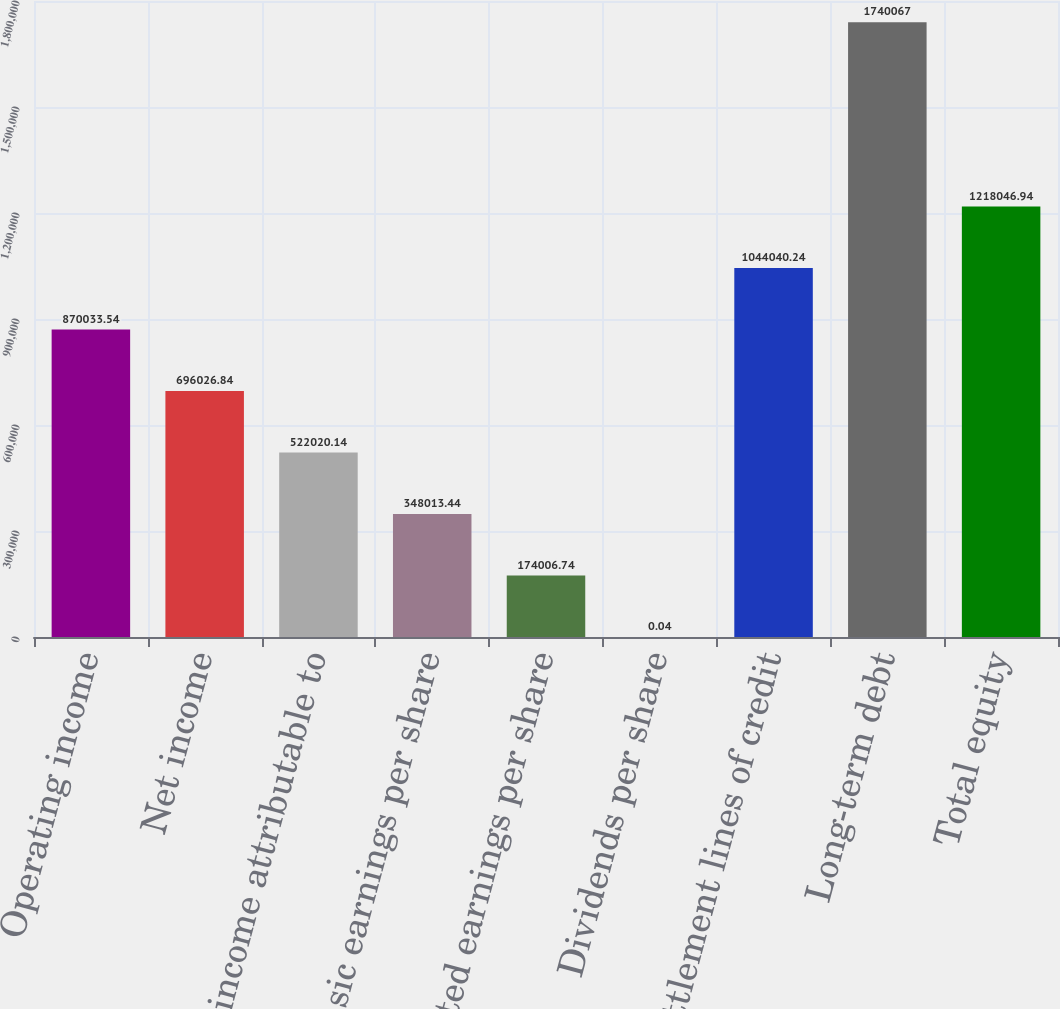Convert chart. <chart><loc_0><loc_0><loc_500><loc_500><bar_chart><fcel>Operating income<fcel>Net income<fcel>Net income attributable to<fcel>Basic earnings per share<fcel>Diluted earnings per share<fcel>Dividends per share<fcel>Settlement lines of credit<fcel>Long-term debt<fcel>Total equity<nl><fcel>870034<fcel>696027<fcel>522020<fcel>348013<fcel>174007<fcel>0.04<fcel>1.04404e+06<fcel>1.74007e+06<fcel>1.21805e+06<nl></chart> 